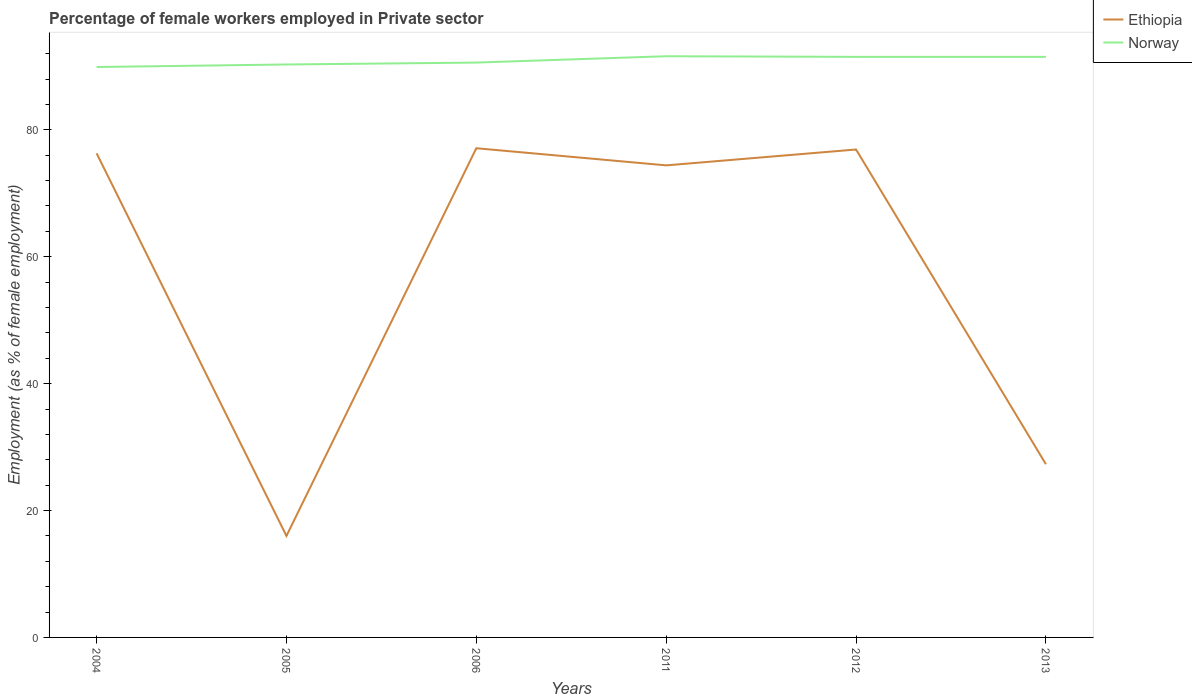Does the line corresponding to Ethiopia intersect with the line corresponding to Norway?
Ensure brevity in your answer.  No. Across all years, what is the maximum percentage of females employed in Private sector in Ethiopia?
Give a very brief answer. 16. What is the total percentage of females employed in Private sector in Ethiopia in the graph?
Your answer should be very brief. -61.1. What is the difference between the highest and the second highest percentage of females employed in Private sector in Ethiopia?
Offer a very short reply. 61.1. Is the percentage of females employed in Private sector in Norway strictly greater than the percentage of females employed in Private sector in Ethiopia over the years?
Offer a terse response. No. How many lines are there?
Provide a short and direct response. 2. What is the difference between two consecutive major ticks on the Y-axis?
Keep it short and to the point. 20. Are the values on the major ticks of Y-axis written in scientific E-notation?
Keep it short and to the point. No. Does the graph contain grids?
Offer a very short reply. No. Where does the legend appear in the graph?
Your answer should be very brief. Top right. How many legend labels are there?
Your answer should be very brief. 2. What is the title of the graph?
Give a very brief answer. Percentage of female workers employed in Private sector. What is the label or title of the Y-axis?
Provide a short and direct response. Employment (as % of female employment). What is the Employment (as % of female employment) in Ethiopia in 2004?
Offer a very short reply. 76.3. What is the Employment (as % of female employment) in Norway in 2004?
Your answer should be compact. 89.9. What is the Employment (as % of female employment) of Ethiopia in 2005?
Keep it short and to the point. 16. What is the Employment (as % of female employment) in Norway in 2005?
Give a very brief answer. 90.3. What is the Employment (as % of female employment) in Ethiopia in 2006?
Ensure brevity in your answer.  77.1. What is the Employment (as % of female employment) of Norway in 2006?
Give a very brief answer. 90.6. What is the Employment (as % of female employment) in Ethiopia in 2011?
Your answer should be very brief. 74.4. What is the Employment (as % of female employment) in Norway in 2011?
Give a very brief answer. 91.6. What is the Employment (as % of female employment) in Ethiopia in 2012?
Keep it short and to the point. 76.9. What is the Employment (as % of female employment) in Norway in 2012?
Provide a succinct answer. 91.5. What is the Employment (as % of female employment) of Ethiopia in 2013?
Ensure brevity in your answer.  27.3. What is the Employment (as % of female employment) of Norway in 2013?
Provide a short and direct response. 91.5. Across all years, what is the maximum Employment (as % of female employment) in Ethiopia?
Offer a very short reply. 77.1. Across all years, what is the maximum Employment (as % of female employment) in Norway?
Make the answer very short. 91.6. Across all years, what is the minimum Employment (as % of female employment) in Norway?
Your answer should be very brief. 89.9. What is the total Employment (as % of female employment) in Ethiopia in the graph?
Your answer should be very brief. 348. What is the total Employment (as % of female employment) in Norway in the graph?
Offer a very short reply. 545.4. What is the difference between the Employment (as % of female employment) in Ethiopia in 2004 and that in 2005?
Make the answer very short. 60.3. What is the difference between the Employment (as % of female employment) in Norway in 2004 and that in 2005?
Offer a terse response. -0.4. What is the difference between the Employment (as % of female employment) in Ethiopia in 2004 and that in 2006?
Your answer should be very brief. -0.8. What is the difference between the Employment (as % of female employment) in Norway in 2004 and that in 2011?
Your answer should be compact. -1.7. What is the difference between the Employment (as % of female employment) in Ethiopia in 2004 and that in 2012?
Your answer should be compact. -0.6. What is the difference between the Employment (as % of female employment) of Norway in 2004 and that in 2012?
Offer a very short reply. -1.6. What is the difference between the Employment (as % of female employment) of Ethiopia in 2004 and that in 2013?
Your response must be concise. 49. What is the difference between the Employment (as % of female employment) in Norway in 2004 and that in 2013?
Provide a short and direct response. -1.6. What is the difference between the Employment (as % of female employment) of Ethiopia in 2005 and that in 2006?
Ensure brevity in your answer.  -61.1. What is the difference between the Employment (as % of female employment) in Norway in 2005 and that in 2006?
Offer a terse response. -0.3. What is the difference between the Employment (as % of female employment) in Ethiopia in 2005 and that in 2011?
Keep it short and to the point. -58.4. What is the difference between the Employment (as % of female employment) of Ethiopia in 2005 and that in 2012?
Give a very brief answer. -60.9. What is the difference between the Employment (as % of female employment) in Norway in 2005 and that in 2012?
Your answer should be compact. -1.2. What is the difference between the Employment (as % of female employment) in Ethiopia in 2005 and that in 2013?
Keep it short and to the point. -11.3. What is the difference between the Employment (as % of female employment) of Ethiopia in 2006 and that in 2011?
Keep it short and to the point. 2.7. What is the difference between the Employment (as % of female employment) of Ethiopia in 2006 and that in 2012?
Keep it short and to the point. 0.2. What is the difference between the Employment (as % of female employment) of Norway in 2006 and that in 2012?
Provide a succinct answer. -0.9. What is the difference between the Employment (as % of female employment) of Ethiopia in 2006 and that in 2013?
Your answer should be very brief. 49.8. What is the difference between the Employment (as % of female employment) of Norway in 2011 and that in 2012?
Ensure brevity in your answer.  0.1. What is the difference between the Employment (as % of female employment) in Ethiopia in 2011 and that in 2013?
Offer a very short reply. 47.1. What is the difference between the Employment (as % of female employment) of Ethiopia in 2012 and that in 2013?
Provide a short and direct response. 49.6. What is the difference between the Employment (as % of female employment) of Ethiopia in 2004 and the Employment (as % of female employment) of Norway in 2006?
Offer a very short reply. -14.3. What is the difference between the Employment (as % of female employment) in Ethiopia in 2004 and the Employment (as % of female employment) in Norway in 2011?
Offer a terse response. -15.3. What is the difference between the Employment (as % of female employment) in Ethiopia in 2004 and the Employment (as % of female employment) in Norway in 2012?
Your response must be concise. -15.2. What is the difference between the Employment (as % of female employment) of Ethiopia in 2004 and the Employment (as % of female employment) of Norway in 2013?
Your response must be concise. -15.2. What is the difference between the Employment (as % of female employment) of Ethiopia in 2005 and the Employment (as % of female employment) of Norway in 2006?
Provide a short and direct response. -74.6. What is the difference between the Employment (as % of female employment) of Ethiopia in 2005 and the Employment (as % of female employment) of Norway in 2011?
Give a very brief answer. -75.6. What is the difference between the Employment (as % of female employment) of Ethiopia in 2005 and the Employment (as % of female employment) of Norway in 2012?
Provide a succinct answer. -75.5. What is the difference between the Employment (as % of female employment) in Ethiopia in 2005 and the Employment (as % of female employment) in Norway in 2013?
Offer a terse response. -75.5. What is the difference between the Employment (as % of female employment) in Ethiopia in 2006 and the Employment (as % of female employment) in Norway in 2011?
Provide a short and direct response. -14.5. What is the difference between the Employment (as % of female employment) in Ethiopia in 2006 and the Employment (as % of female employment) in Norway in 2012?
Give a very brief answer. -14.4. What is the difference between the Employment (as % of female employment) of Ethiopia in 2006 and the Employment (as % of female employment) of Norway in 2013?
Offer a terse response. -14.4. What is the difference between the Employment (as % of female employment) of Ethiopia in 2011 and the Employment (as % of female employment) of Norway in 2012?
Ensure brevity in your answer.  -17.1. What is the difference between the Employment (as % of female employment) in Ethiopia in 2011 and the Employment (as % of female employment) in Norway in 2013?
Provide a short and direct response. -17.1. What is the difference between the Employment (as % of female employment) in Ethiopia in 2012 and the Employment (as % of female employment) in Norway in 2013?
Offer a very short reply. -14.6. What is the average Employment (as % of female employment) of Ethiopia per year?
Offer a very short reply. 58. What is the average Employment (as % of female employment) in Norway per year?
Your answer should be very brief. 90.9. In the year 2004, what is the difference between the Employment (as % of female employment) of Ethiopia and Employment (as % of female employment) of Norway?
Provide a short and direct response. -13.6. In the year 2005, what is the difference between the Employment (as % of female employment) of Ethiopia and Employment (as % of female employment) of Norway?
Offer a terse response. -74.3. In the year 2011, what is the difference between the Employment (as % of female employment) in Ethiopia and Employment (as % of female employment) in Norway?
Provide a succinct answer. -17.2. In the year 2012, what is the difference between the Employment (as % of female employment) in Ethiopia and Employment (as % of female employment) in Norway?
Offer a terse response. -14.6. In the year 2013, what is the difference between the Employment (as % of female employment) of Ethiopia and Employment (as % of female employment) of Norway?
Make the answer very short. -64.2. What is the ratio of the Employment (as % of female employment) in Ethiopia in 2004 to that in 2005?
Offer a terse response. 4.77. What is the ratio of the Employment (as % of female employment) of Ethiopia in 2004 to that in 2006?
Keep it short and to the point. 0.99. What is the ratio of the Employment (as % of female employment) of Norway in 2004 to that in 2006?
Your response must be concise. 0.99. What is the ratio of the Employment (as % of female employment) in Ethiopia in 2004 to that in 2011?
Your answer should be very brief. 1.03. What is the ratio of the Employment (as % of female employment) in Norway in 2004 to that in 2011?
Provide a short and direct response. 0.98. What is the ratio of the Employment (as % of female employment) in Ethiopia in 2004 to that in 2012?
Offer a terse response. 0.99. What is the ratio of the Employment (as % of female employment) of Norway in 2004 to that in 2012?
Ensure brevity in your answer.  0.98. What is the ratio of the Employment (as % of female employment) in Ethiopia in 2004 to that in 2013?
Keep it short and to the point. 2.79. What is the ratio of the Employment (as % of female employment) in Norway in 2004 to that in 2013?
Give a very brief answer. 0.98. What is the ratio of the Employment (as % of female employment) in Ethiopia in 2005 to that in 2006?
Provide a succinct answer. 0.21. What is the ratio of the Employment (as % of female employment) in Ethiopia in 2005 to that in 2011?
Provide a succinct answer. 0.22. What is the ratio of the Employment (as % of female employment) in Norway in 2005 to that in 2011?
Provide a short and direct response. 0.99. What is the ratio of the Employment (as % of female employment) in Ethiopia in 2005 to that in 2012?
Your answer should be very brief. 0.21. What is the ratio of the Employment (as % of female employment) of Norway in 2005 to that in 2012?
Your answer should be very brief. 0.99. What is the ratio of the Employment (as % of female employment) of Ethiopia in 2005 to that in 2013?
Your answer should be compact. 0.59. What is the ratio of the Employment (as % of female employment) in Norway in 2005 to that in 2013?
Make the answer very short. 0.99. What is the ratio of the Employment (as % of female employment) of Ethiopia in 2006 to that in 2011?
Your answer should be compact. 1.04. What is the ratio of the Employment (as % of female employment) of Norway in 2006 to that in 2011?
Ensure brevity in your answer.  0.99. What is the ratio of the Employment (as % of female employment) in Ethiopia in 2006 to that in 2012?
Offer a very short reply. 1. What is the ratio of the Employment (as % of female employment) in Norway in 2006 to that in 2012?
Your answer should be compact. 0.99. What is the ratio of the Employment (as % of female employment) of Ethiopia in 2006 to that in 2013?
Give a very brief answer. 2.82. What is the ratio of the Employment (as % of female employment) in Norway in 2006 to that in 2013?
Your answer should be very brief. 0.99. What is the ratio of the Employment (as % of female employment) in Ethiopia in 2011 to that in 2012?
Give a very brief answer. 0.97. What is the ratio of the Employment (as % of female employment) of Norway in 2011 to that in 2012?
Your answer should be very brief. 1. What is the ratio of the Employment (as % of female employment) of Ethiopia in 2011 to that in 2013?
Keep it short and to the point. 2.73. What is the ratio of the Employment (as % of female employment) in Norway in 2011 to that in 2013?
Your response must be concise. 1. What is the ratio of the Employment (as % of female employment) of Ethiopia in 2012 to that in 2013?
Your answer should be very brief. 2.82. What is the ratio of the Employment (as % of female employment) of Norway in 2012 to that in 2013?
Your answer should be very brief. 1. What is the difference between the highest and the second highest Employment (as % of female employment) in Ethiopia?
Your response must be concise. 0.2. What is the difference between the highest and the second highest Employment (as % of female employment) of Norway?
Your answer should be very brief. 0.1. What is the difference between the highest and the lowest Employment (as % of female employment) in Ethiopia?
Provide a succinct answer. 61.1. 